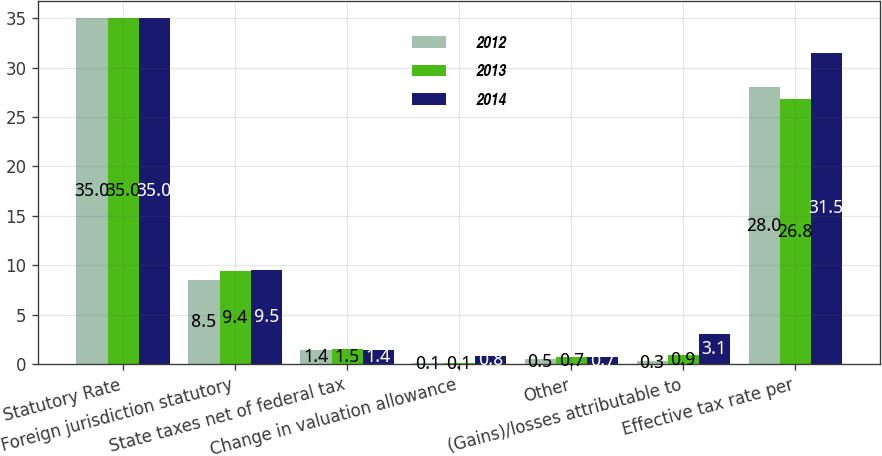Convert chart to OTSL. <chart><loc_0><loc_0><loc_500><loc_500><stacked_bar_chart><ecel><fcel>Statutory Rate<fcel>Foreign jurisdiction statutory<fcel>State taxes net of federal tax<fcel>Change in valuation allowance<fcel>Other<fcel>(Gains)/losses attributable to<fcel>Effective tax rate per<nl><fcel>2012<fcel>35<fcel>8.5<fcel>1.4<fcel>0.1<fcel>0.5<fcel>0.3<fcel>28<nl><fcel>2013<fcel>35<fcel>9.4<fcel>1.5<fcel>0.1<fcel>0.7<fcel>0.9<fcel>26.8<nl><fcel>2014<fcel>35<fcel>9.5<fcel>1.4<fcel>0.8<fcel>0.7<fcel>3.1<fcel>31.5<nl></chart> 